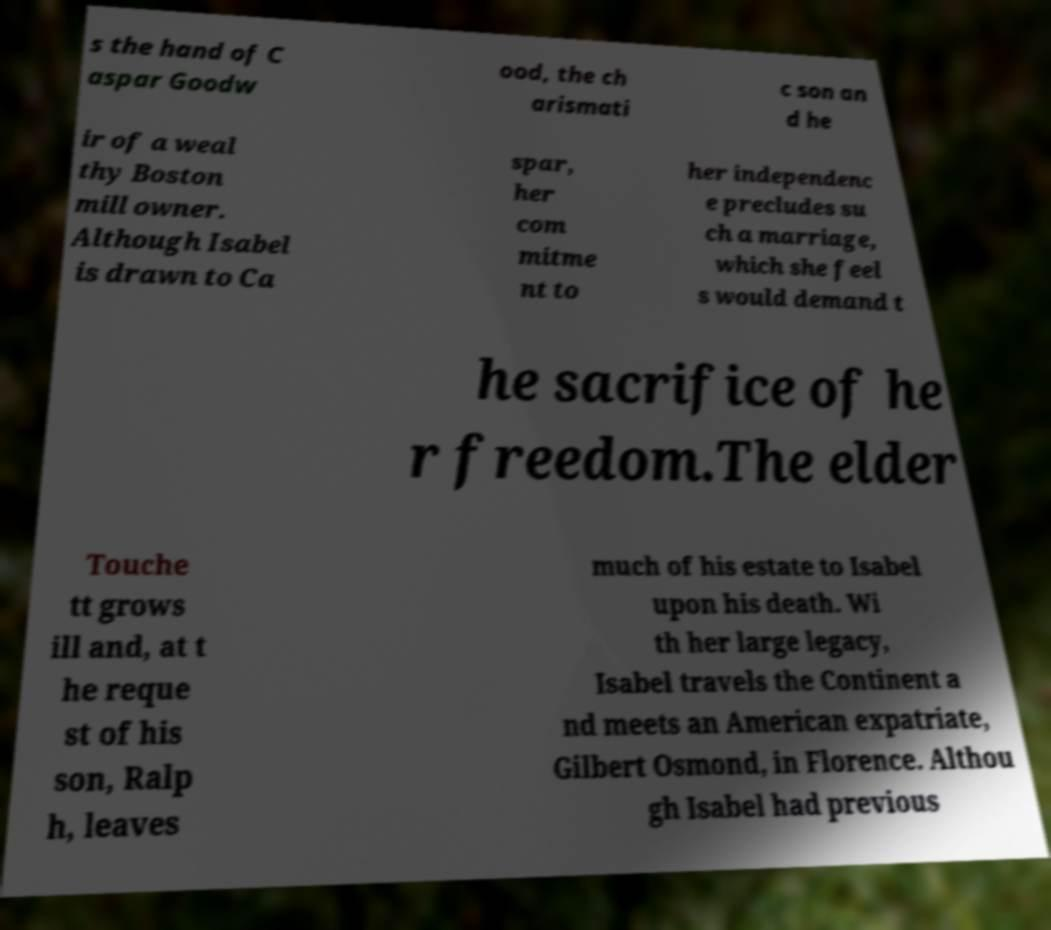Please identify and transcribe the text found in this image. s the hand of C aspar Goodw ood, the ch arismati c son an d he ir of a weal thy Boston mill owner. Although Isabel is drawn to Ca spar, her com mitme nt to her independenc e precludes su ch a marriage, which she feel s would demand t he sacrifice of he r freedom.The elder Touche tt grows ill and, at t he reque st of his son, Ralp h, leaves much of his estate to Isabel upon his death. Wi th her large legacy, Isabel travels the Continent a nd meets an American expatriate, Gilbert Osmond, in Florence. Althou gh Isabel had previous 